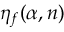<formula> <loc_0><loc_0><loc_500><loc_500>\eta _ { f } ( \alpha , n )</formula> 